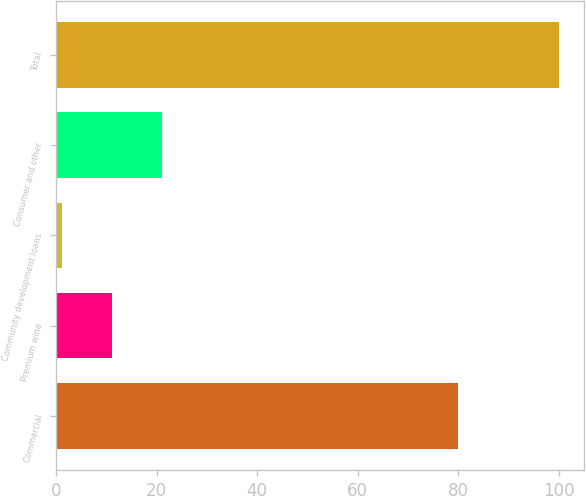<chart> <loc_0><loc_0><loc_500><loc_500><bar_chart><fcel>Commercial<fcel>Premium wine<fcel>Community development loans<fcel>Consumer and other<fcel>Total<nl><fcel>80<fcel>11.17<fcel>1.3<fcel>21.04<fcel>100<nl></chart> 